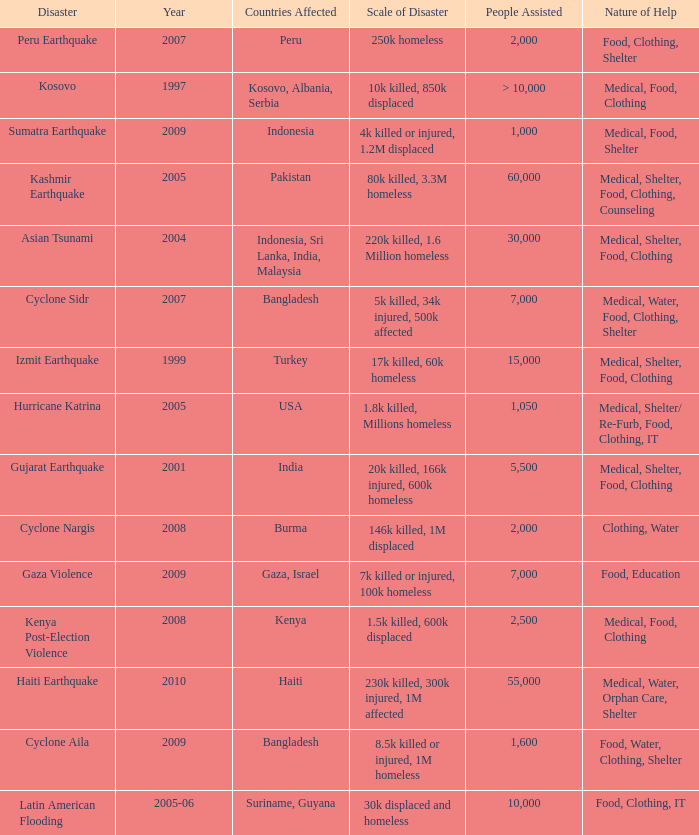How many people were assisted in 1997? > 10,000. 